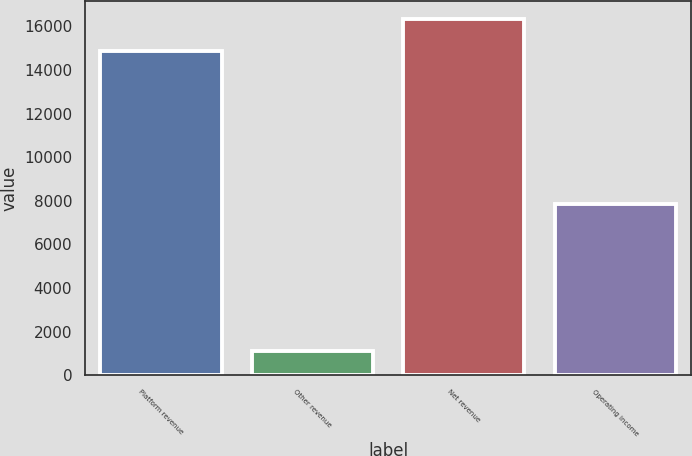<chart> <loc_0><loc_0><loc_500><loc_500><bar_chart><fcel>Platform revenue<fcel>Other revenue<fcel>Net revenue<fcel>Operating income<nl><fcel>14856<fcel>1125<fcel>16341.6<fcel>7847<nl></chart> 